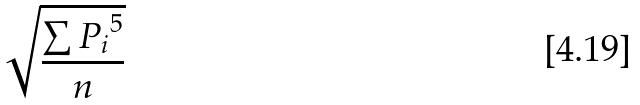Convert formula to latex. <formula><loc_0><loc_0><loc_500><loc_500>\sqrt { \frac { \sum { P _ { i } } ^ { 5 } } { n } }</formula> 